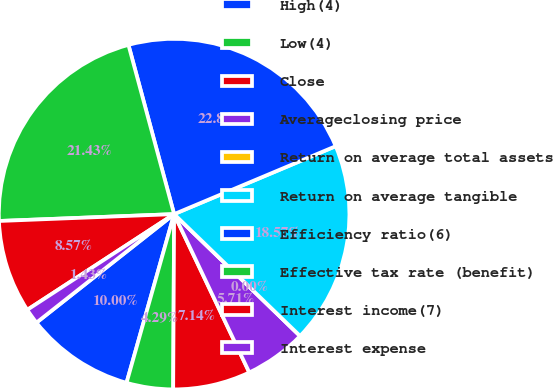<chart> <loc_0><loc_0><loc_500><loc_500><pie_chart><fcel>High(4)<fcel>Low(4)<fcel>Close<fcel>Averageclosing price<fcel>Return on average total assets<fcel>Return on average tangible<fcel>Efficiency ratio(6)<fcel>Effective tax rate (benefit)<fcel>Interest income(7)<fcel>Interest expense<nl><fcel>10.0%<fcel>4.29%<fcel>7.14%<fcel>5.71%<fcel>0.0%<fcel>18.57%<fcel>22.86%<fcel>21.43%<fcel>8.57%<fcel>1.43%<nl></chart> 